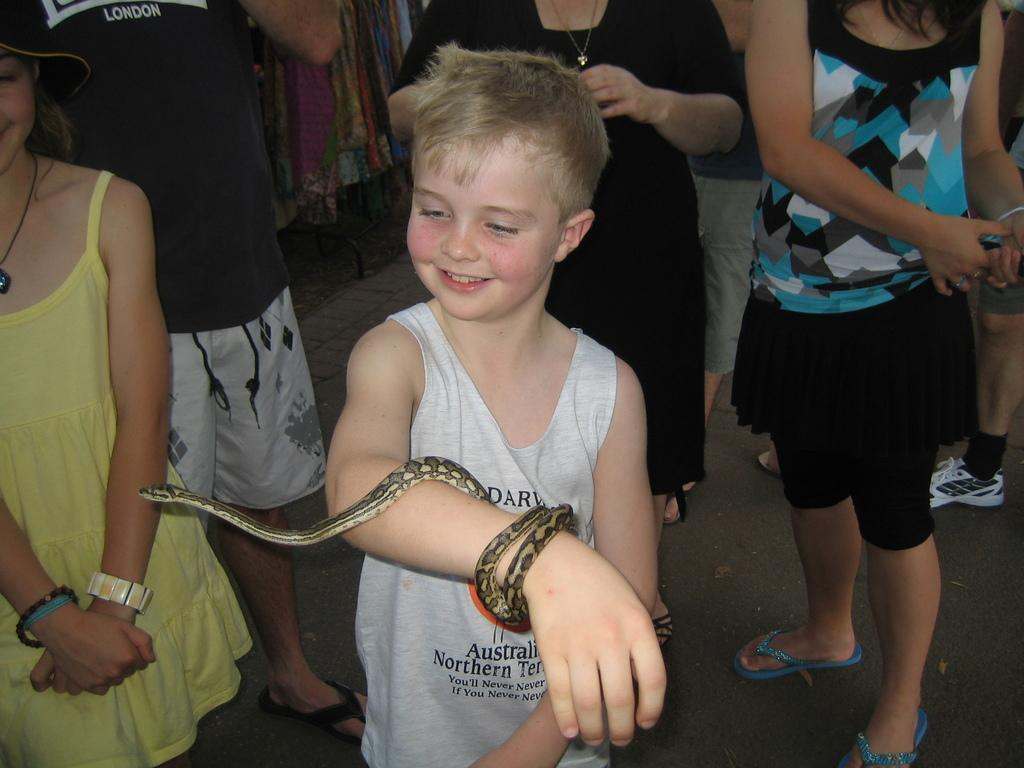What is the main subject of the image? The main subject of the image is a child. What is the child doing in the image? The child is standing in the image. Is there any animal present in the image? Yes, there is a snake on the child's right hand. Can you describe the background of the image? There are people standing in the background of the image. What type of toys can be seen in the hands of the man in the image? There is no man present in the image, and therefore no toys can be seen in his hands. 